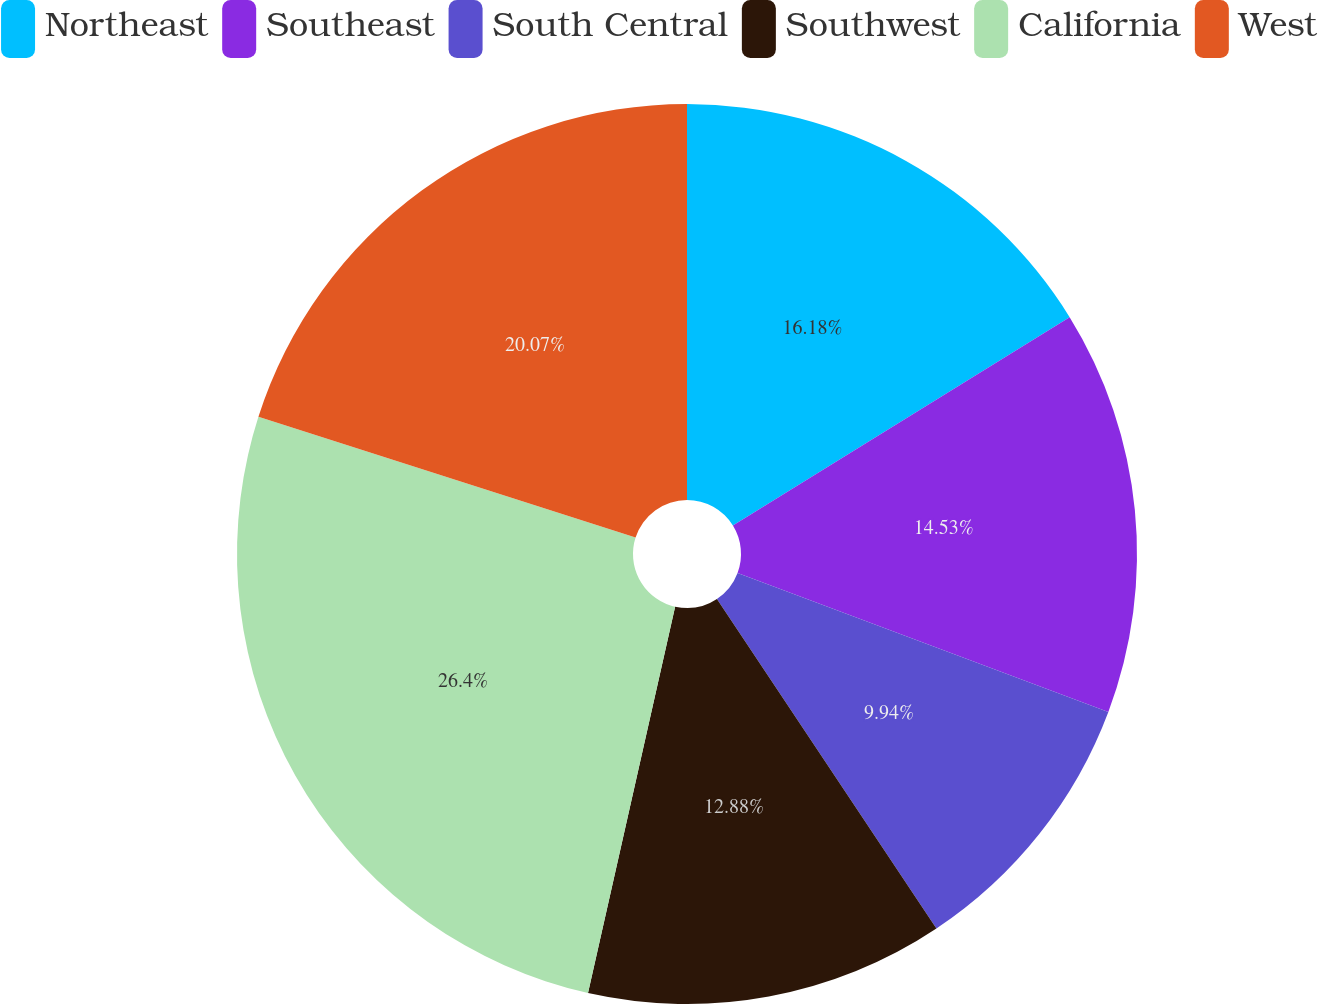Convert chart. <chart><loc_0><loc_0><loc_500><loc_500><pie_chart><fcel>Northeast<fcel>Southeast<fcel>South Central<fcel>Southwest<fcel>California<fcel>West<nl><fcel>16.18%<fcel>14.53%<fcel>9.94%<fcel>12.88%<fcel>26.4%<fcel>20.07%<nl></chart> 